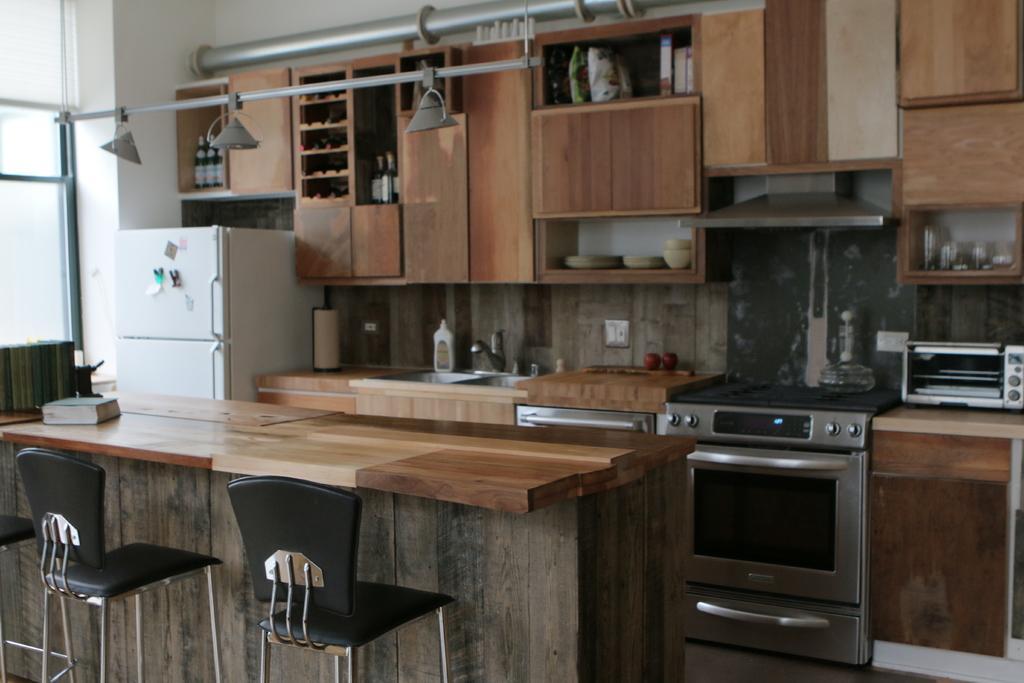Describe this image in one or two sentences. This is the picture of the kitchen. In the front there are two chairs and there is a book on the table. At the left there is a stove and micro oven and glass in the cupboard and in the middle there is a sink. There are plates and bowls on the cupboard. At the right there is a refrigerator and bottles on the table and at the top there are lights. 